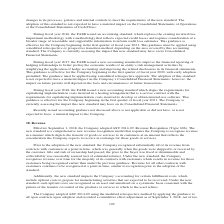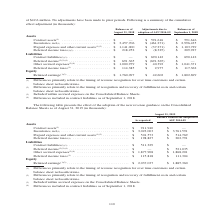According to Jabil Circuit's financial document, What were the Adjustments due to adoption of ASU 2014-09 for contract assets? According to the financial document, $591,616 (in thousands). The relevant text states: "Assets Contract assets (1) . $ — $ 591,616 $ 591,616 Inventories, net (1) . $ 3,457,706 $ (461,271) $ 2,996,435 Prepaid expenses and other cur..." Also, What does the new standard entail? a comprehensive new revenue recognition model that requires the Company to recognize revenue in a manner which depicts the transfer of goods or services to its customers at an amount that reflects the consideration the Company expects to receive in exchange for those goods or services. The document states: "enue Recognition (Topic 606). The new standard is a comprehensive new revenue recognition model that requires the Company to recognize revenue in a ma..." Also, What was the balance as of September 1, 2018 for contract liabilities? According to the financial document, $690,142 (in thousands). The relevant text states: "7 Liabilities Contract liabilities (2)(3) . $ — $ 690,142 $ 690,142 Deferred income (2)(3)(4) . $ 691,365 $ (691,365) $ — Other accrued expenses (3)(4) . $ 1..." Also, can you calculate: What is the difference between the balance in September 2018 for contract assets and contract liabilities? Based on the calculation: 690,142-591,616, the result is 98526 (in thousands). This is based on the information: "Assets Contract assets (1) . $ — $ 591,616 $ 591,616 Inventories, net (1) . $ 3,457,706 $ (461,271) $ 2,996,435 Prepaid expenses and other cur 7 Liabilities Contract liabilities (2)(3) . $ — $ 690,142..." The key data points involved are: 591,616, 690,142. Also, can you calculate: What was the percentage change for Other accrued expenses due to adjustments by the new standard? Based on the calculation: $40,392/$1,000,979, the result is 4.04 (percentage). This is based on the information: "$ (691,365) $ — Other accrued expenses (3)(4) . $ 1,000,979 $ 40,392 $ 1,041,371 Deferred income taxes (1) . $ 114,385 $ 2,977 $ 117,362 Equity Retained earnin $ — Other accrued expenses (3)(4) . $ 1,..." The key data points involved are: 1,000,979, 40,392. Also, can you calculate: What was the percentage change in the balance of retained earnings due to adjustments by the new standard? To answer this question, I need to perform calculations using the financial data. The calculation is: (1,802,699-1,760,097)/1,760,097, which equals 2.42 (percentage). This is based on the information: "977 $ 117,362 Equity Retained earnings (1)(2) . $ 1,760,097 $ 42,602 $ 1,802,699 Retained earnings (1)(2) . $ 1,760,097 $ 42,602 $ 1,802,699..." The key data points involved are: 1,760,097, 1,802,699. 